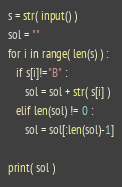Convert code to text. <code><loc_0><loc_0><loc_500><loc_500><_Python_>s = str( input() )
sol = ""
for i in range( len(s) ) :
   if s[i]!="B" :
      sol = sol + str( s[i] )
   elif len(sol) != 0 :
      sol = sol[:len(sol)-1]

print( sol )</code> 